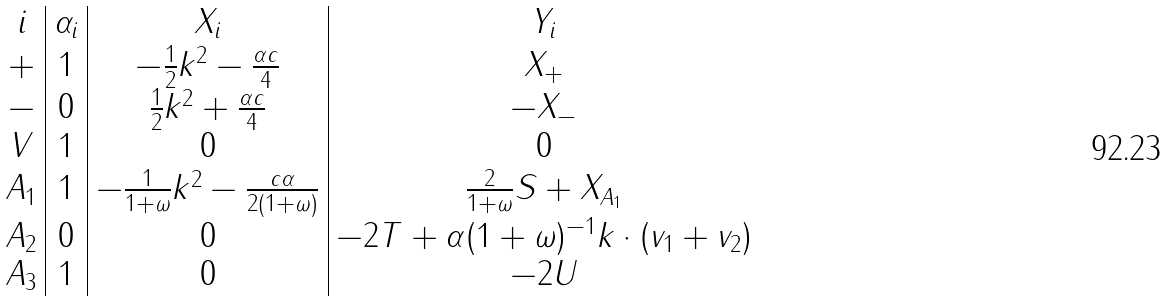<formula> <loc_0><loc_0><loc_500><loc_500>\begin{array} { c | c | c | c } i & \alpha _ { i } & X _ { i } & Y _ { i } \\ + & 1 & - \frac { 1 } { 2 } k ^ { 2 } - \frac { \alpha c } { 4 } & X _ { + } \\ - & 0 & \frac { 1 } { 2 } k ^ { 2 } + \frac { \alpha c } { 4 } & - X _ { - } \\ V & 1 & 0 & 0 \\ A _ { 1 } & 1 & - \frac { 1 } { 1 + \omega } k ^ { 2 } - \frac { c \alpha } { 2 ( 1 + \omega ) } & \frac { 2 } { 1 + \omega } S + X _ { A _ { 1 } } \\ A _ { 2 } & 0 & 0 & - 2 T + \alpha ( 1 + \omega ) ^ { - 1 } k \cdot ( v _ { 1 } + v _ { 2 } ) \\ A _ { 3 } & 1 & 0 & - 2 U \end{array}</formula> 